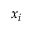Convert formula to latex. <formula><loc_0><loc_0><loc_500><loc_500>x _ { i }</formula> 